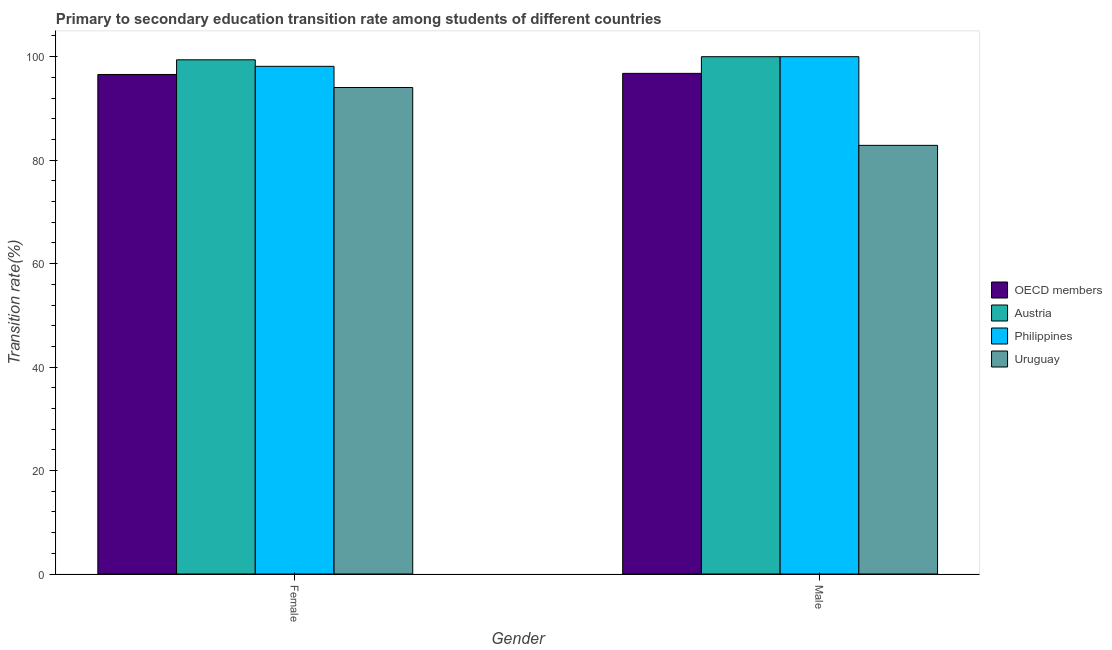How many different coloured bars are there?
Your answer should be very brief. 4. How many bars are there on the 1st tick from the right?
Keep it short and to the point. 4. What is the label of the 2nd group of bars from the left?
Keep it short and to the point. Male. Across all countries, what is the maximum transition rate among male students?
Make the answer very short. 100. Across all countries, what is the minimum transition rate among male students?
Offer a very short reply. 82.86. In which country was the transition rate among female students minimum?
Keep it short and to the point. Uruguay. What is the total transition rate among male students in the graph?
Give a very brief answer. 379.64. What is the difference between the transition rate among female students in Austria and that in Uruguay?
Your answer should be very brief. 5.35. What is the difference between the transition rate among female students in Uruguay and the transition rate among male students in Philippines?
Make the answer very short. -5.96. What is the average transition rate among female students per country?
Make the answer very short. 97.03. What is the difference between the transition rate among male students and transition rate among female students in Philippines?
Provide a succinct answer. 1.86. What is the ratio of the transition rate among female students in Uruguay to that in OECD members?
Provide a succinct answer. 0.97. Is the transition rate among female students in Uruguay less than that in Austria?
Your answer should be compact. Yes. What does the 4th bar from the left in Male represents?
Offer a terse response. Uruguay. What does the 3rd bar from the right in Female represents?
Your answer should be very brief. Austria. How many bars are there?
Give a very brief answer. 8. Are all the bars in the graph horizontal?
Your answer should be very brief. No. What is the difference between two consecutive major ticks on the Y-axis?
Your answer should be very brief. 20. Does the graph contain grids?
Provide a short and direct response. No. Where does the legend appear in the graph?
Keep it short and to the point. Center right. How many legend labels are there?
Your response must be concise. 4. What is the title of the graph?
Keep it short and to the point. Primary to secondary education transition rate among students of different countries. Does "Bahrain" appear as one of the legend labels in the graph?
Your answer should be very brief. No. What is the label or title of the X-axis?
Provide a succinct answer. Gender. What is the label or title of the Y-axis?
Provide a short and direct response. Transition rate(%). What is the Transition rate(%) of OECD members in Female?
Provide a succinct answer. 96.56. What is the Transition rate(%) in Austria in Female?
Offer a very short reply. 99.4. What is the Transition rate(%) of Philippines in Female?
Provide a short and direct response. 98.14. What is the Transition rate(%) of Uruguay in Female?
Ensure brevity in your answer.  94.04. What is the Transition rate(%) of OECD members in Male?
Keep it short and to the point. 96.78. What is the Transition rate(%) of Philippines in Male?
Your answer should be very brief. 100. What is the Transition rate(%) of Uruguay in Male?
Make the answer very short. 82.86. Across all Gender, what is the maximum Transition rate(%) of OECD members?
Give a very brief answer. 96.78. Across all Gender, what is the maximum Transition rate(%) of Austria?
Ensure brevity in your answer.  100. Across all Gender, what is the maximum Transition rate(%) of Philippines?
Give a very brief answer. 100. Across all Gender, what is the maximum Transition rate(%) of Uruguay?
Provide a succinct answer. 94.04. Across all Gender, what is the minimum Transition rate(%) of OECD members?
Keep it short and to the point. 96.56. Across all Gender, what is the minimum Transition rate(%) in Austria?
Your answer should be compact. 99.4. Across all Gender, what is the minimum Transition rate(%) of Philippines?
Your answer should be compact. 98.14. Across all Gender, what is the minimum Transition rate(%) in Uruguay?
Ensure brevity in your answer.  82.86. What is the total Transition rate(%) in OECD members in the graph?
Your answer should be compact. 193.34. What is the total Transition rate(%) in Austria in the graph?
Make the answer very short. 199.4. What is the total Transition rate(%) of Philippines in the graph?
Ensure brevity in your answer.  198.14. What is the total Transition rate(%) of Uruguay in the graph?
Provide a short and direct response. 176.9. What is the difference between the Transition rate(%) of OECD members in Female and that in Male?
Offer a terse response. -0.21. What is the difference between the Transition rate(%) of Austria in Female and that in Male?
Provide a succinct answer. -0.6. What is the difference between the Transition rate(%) of Philippines in Female and that in Male?
Keep it short and to the point. -1.86. What is the difference between the Transition rate(%) in Uruguay in Female and that in Male?
Your answer should be compact. 11.18. What is the difference between the Transition rate(%) in OECD members in Female and the Transition rate(%) in Austria in Male?
Provide a succinct answer. -3.44. What is the difference between the Transition rate(%) in OECD members in Female and the Transition rate(%) in Philippines in Male?
Your response must be concise. -3.44. What is the difference between the Transition rate(%) in OECD members in Female and the Transition rate(%) in Uruguay in Male?
Give a very brief answer. 13.7. What is the difference between the Transition rate(%) in Austria in Female and the Transition rate(%) in Philippines in Male?
Your response must be concise. -0.6. What is the difference between the Transition rate(%) of Austria in Female and the Transition rate(%) of Uruguay in Male?
Offer a very short reply. 16.53. What is the difference between the Transition rate(%) of Philippines in Female and the Transition rate(%) of Uruguay in Male?
Your answer should be compact. 15.27. What is the average Transition rate(%) in OECD members per Gender?
Provide a short and direct response. 96.67. What is the average Transition rate(%) in Austria per Gender?
Ensure brevity in your answer.  99.7. What is the average Transition rate(%) of Philippines per Gender?
Keep it short and to the point. 99.07. What is the average Transition rate(%) in Uruguay per Gender?
Make the answer very short. 88.45. What is the difference between the Transition rate(%) in OECD members and Transition rate(%) in Austria in Female?
Your answer should be compact. -2.83. What is the difference between the Transition rate(%) of OECD members and Transition rate(%) of Philippines in Female?
Make the answer very short. -1.57. What is the difference between the Transition rate(%) of OECD members and Transition rate(%) of Uruguay in Female?
Offer a very short reply. 2.52. What is the difference between the Transition rate(%) in Austria and Transition rate(%) in Philippines in Female?
Give a very brief answer. 1.26. What is the difference between the Transition rate(%) of Austria and Transition rate(%) of Uruguay in Female?
Provide a succinct answer. 5.35. What is the difference between the Transition rate(%) in Philippines and Transition rate(%) in Uruguay in Female?
Offer a very short reply. 4.09. What is the difference between the Transition rate(%) of OECD members and Transition rate(%) of Austria in Male?
Your response must be concise. -3.22. What is the difference between the Transition rate(%) of OECD members and Transition rate(%) of Philippines in Male?
Provide a short and direct response. -3.22. What is the difference between the Transition rate(%) of OECD members and Transition rate(%) of Uruguay in Male?
Keep it short and to the point. 13.91. What is the difference between the Transition rate(%) of Austria and Transition rate(%) of Philippines in Male?
Make the answer very short. 0. What is the difference between the Transition rate(%) of Austria and Transition rate(%) of Uruguay in Male?
Make the answer very short. 17.14. What is the difference between the Transition rate(%) of Philippines and Transition rate(%) of Uruguay in Male?
Your answer should be very brief. 17.14. What is the ratio of the Transition rate(%) in OECD members in Female to that in Male?
Your answer should be compact. 1. What is the ratio of the Transition rate(%) in Philippines in Female to that in Male?
Offer a very short reply. 0.98. What is the ratio of the Transition rate(%) in Uruguay in Female to that in Male?
Ensure brevity in your answer.  1.13. What is the difference between the highest and the second highest Transition rate(%) in OECD members?
Provide a short and direct response. 0.21. What is the difference between the highest and the second highest Transition rate(%) in Austria?
Give a very brief answer. 0.6. What is the difference between the highest and the second highest Transition rate(%) in Philippines?
Offer a terse response. 1.86. What is the difference between the highest and the second highest Transition rate(%) in Uruguay?
Ensure brevity in your answer.  11.18. What is the difference between the highest and the lowest Transition rate(%) in OECD members?
Your answer should be compact. 0.21. What is the difference between the highest and the lowest Transition rate(%) in Austria?
Give a very brief answer. 0.6. What is the difference between the highest and the lowest Transition rate(%) in Philippines?
Your answer should be very brief. 1.86. What is the difference between the highest and the lowest Transition rate(%) in Uruguay?
Keep it short and to the point. 11.18. 